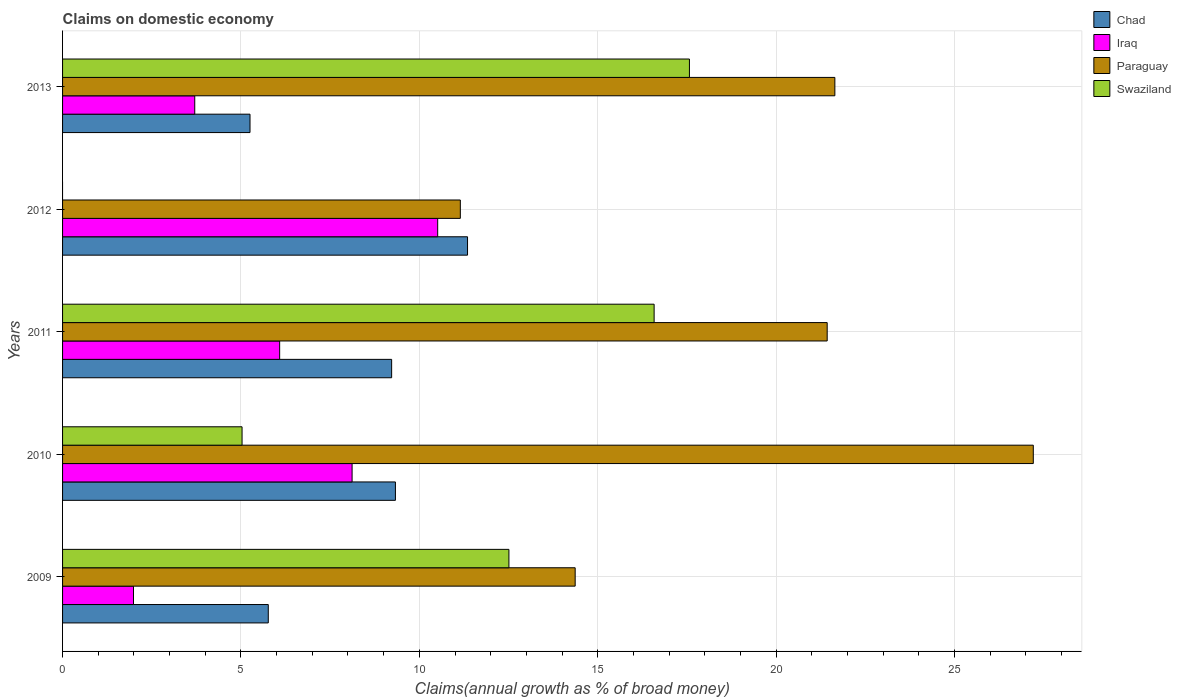How many groups of bars are there?
Your answer should be compact. 5. How many bars are there on the 3rd tick from the top?
Your response must be concise. 4. How many bars are there on the 2nd tick from the bottom?
Keep it short and to the point. 4. What is the label of the 5th group of bars from the top?
Your answer should be compact. 2009. What is the percentage of broad money claimed on domestic economy in Iraq in 2010?
Keep it short and to the point. 8.12. Across all years, what is the maximum percentage of broad money claimed on domestic economy in Chad?
Keep it short and to the point. 11.35. Across all years, what is the minimum percentage of broad money claimed on domestic economy in Paraguay?
Keep it short and to the point. 11.15. In which year was the percentage of broad money claimed on domestic economy in Chad maximum?
Keep it short and to the point. 2012. What is the total percentage of broad money claimed on domestic economy in Iraq in the graph?
Provide a succinct answer. 30.41. What is the difference between the percentage of broad money claimed on domestic economy in Swaziland in 2009 and that in 2010?
Make the answer very short. 7.48. What is the difference between the percentage of broad money claimed on domestic economy in Iraq in 2010 and the percentage of broad money claimed on domestic economy in Paraguay in 2013?
Ensure brevity in your answer.  -13.53. What is the average percentage of broad money claimed on domestic economy in Swaziland per year?
Make the answer very short. 10.34. In the year 2009, what is the difference between the percentage of broad money claimed on domestic economy in Iraq and percentage of broad money claimed on domestic economy in Chad?
Keep it short and to the point. -3.78. In how many years, is the percentage of broad money claimed on domestic economy in Chad greater than 7 %?
Provide a succinct answer. 3. What is the ratio of the percentage of broad money claimed on domestic economy in Chad in 2011 to that in 2013?
Give a very brief answer. 1.76. Is the percentage of broad money claimed on domestic economy in Paraguay in 2009 less than that in 2011?
Offer a very short reply. Yes. What is the difference between the highest and the second highest percentage of broad money claimed on domestic economy in Swaziland?
Make the answer very short. 0.99. What is the difference between the highest and the lowest percentage of broad money claimed on domestic economy in Chad?
Your response must be concise. 6.1. Is it the case that in every year, the sum of the percentage of broad money claimed on domestic economy in Paraguay and percentage of broad money claimed on domestic economy in Iraq is greater than the sum of percentage of broad money claimed on domestic economy in Swaziland and percentage of broad money claimed on domestic economy in Chad?
Your response must be concise. Yes. How many bars are there?
Give a very brief answer. 19. How many years are there in the graph?
Provide a short and direct response. 5. What is the difference between two consecutive major ticks on the X-axis?
Keep it short and to the point. 5. Where does the legend appear in the graph?
Ensure brevity in your answer.  Top right. How many legend labels are there?
Provide a short and direct response. 4. How are the legend labels stacked?
Provide a short and direct response. Vertical. What is the title of the graph?
Provide a succinct answer. Claims on domestic economy. What is the label or title of the X-axis?
Your response must be concise. Claims(annual growth as % of broad money). What is the Claims(annual growth as % of broad money) in Chad in 2009?
Provide a short and direct response. 5.77. What is the Claims(annual growth as % of broad money) of Iraq in 2009?
Your answer should be compact. 1.99. What is the Claims(annual growth as % of broad money) of Paraguay in 2009?
Ensure brevity in your answer.  14.37. What is the Claims(annual growth as % of broad money) of Swaziland in 2009?
Ensure brevity in your answer.  12.51. What is the Claims(annual growth as % of broad money) in Chad in 2010?
Your answer should be compact. 9.33. What is the Claims(annual growth as % of broad money) in Iraq in 2010?
Make the answer very short. 8.12. What is the Claims(annual growth as % of broad money) of Paraguay in 2010?
Your answer should be compact. 27.21. What is the Claims(annual growth as % of broad money) of Swaziland in 2010?
Your response must be concise. 5.03. What is the Claims(annual growth as % of broad money) in Chad in 2011?
Keep it short and to the point. 9.22. What is the Claims(annual growth as % of broad money) of Iraq in 2011?
Your answer should be very brief. 6.09. What is the Claims(annual growth as % of broad money) of Paraguay in 2011?
Give a very brief answer. 21.43. What is the Claims(annual growth as % of broad money) of Swaziland in 2011?
Offer a very short reply. 16.58. What is the Claims(annual growth as % of broad money) of Chad in 2012?
Offer a very short reply. 11.35. What is the Claims(annual growth as % of broad money) in Iraq in 2012?
Your response must be concise. 10.51. What is the Claims(annual growth as % of broad money) of Paraguay in 2012?
Make the answer very short. 11.15. What is the Claims(annual growth as % of broad money) of Chad in 2013?
Ensure brevity in your answer.  5.25. What is the Claims(annual growth as % of broad money) in Iraq in 2013?
Your answer should be very brief. 3.71. What is the Claims(annual growth as % of broad money) in Paraguay in 2013?
Your answer should be compact. 21.65. What is the Claims(annual growth as % of broad money) of Swaziland in 2013?
Keep it short and to the point. 17.57. Across all years, what is the maximum Claims(annual growth as % of broad money) of Chad?
Ensure brevity in your answer.  11.35. Across all years, what is the maximum Claims(annual growth as % of broad money) of Iraq?
Your answer should be compact. 10.51. Across all years, what is the maximum Claims(annual growth as % of broad money) of Paraguay?
Offer a very short reply. 27.21. Across all years, what is the maximum Claims(annual growth as % of broad money) in Swaziland?
Your answer should be compact. 17.57. Across all years, what is the minimum Claims(annual growth as % of broad money) of Chad?
Your answer should be compact. 5.25. Across all years, what is the minimum Claims(annual growth as % of broad money) of Iraq?
Provide a short and direct response. 1.99. Across all years, what is the minimum Claims(annual growth as % of broad money) of Paraguay?
Your response must be concise. 11.15. Across all years, what is the minimum Claims(annual growth as % of broad money) in Swaziland?
Offer a very short reply. 0. What is the total Claims(annual growth as % of broad money) in Chad in the graph?
Offer a very short reply. 40.93. What is the total Claims(annual growth as % of broad money) of Iraq in the graph?
Provide a short and direct response. 30.41. What is the total Claims(annual growth as % of broad money) in Paraguay in the graph?
Make the answer very short. 95.81. What is the total Claims(annual growth as % of broad money) of Swaziland in the graph?
Your answer should be compact. 51.7. What is the difference between the Claims(annual growth as % of broad money) of Chad in 2009 and that in 2010?
Keep it short and to the point. -3.56. What is the difference between the Claims(annual growth as % of broad money) of Iraq in 2009 and that in 2010?
Your answer should be compact. -6.13. What is the difference between the Claims(annual growth as % of broad money) of Paraguay in 2009 and that in 2010?
Provide a short and direct response. -12.84. What is the difference between the Claims(annual growth as % of broad money) of Swaziland in 2009 and that in 2010?
Offer a terse response. 7.48. What is the difference between the Claims(annual growth as % of broad money) of Chad in 2009 and that in 2011?
Provide a succinct answer. -3.46. What is the difference between the Claims(annual growth as % of broad money) in Iraq in 2009 and that in 2011?
Give a very brief answer. -4.1. What is the difference between the Claims(annual growth as % of broad money) in Paraguay in 2009 and that in 2011?
Keep it short and to the point. -7.06. What is the difference between the Claims(annual growth as % of broad money) of Swaziland in 2009 and that in 2011?
Ensure brevity in your answer.  -4.07. What is the difference between the Claims(annual growth as % of broad money) of Chad in 2009 and that in 2012?
Give a very brief answer. -5.59. What is the difference between the Claims(annual growth as % of broad money) of Iraq in 2009 and that in 2012?
Offer a terse response. -8.53. What is the difference between the Claims(annual growth as % of broad money) of Paraguay in 2009 and that in 2012?
Offer a very short reply. 3.22. What is the difference between the Claims(annual growth as % of broad money) of Chad in 2009 and that in 2013?
Provide a succinct answer. 0.51. What is the difference between the Claims(annual growth as % of broad money) in Iraq in 2009 and that in 2013?
Your answer should be compact. -1.72. What is the difference between the Claims(annual growth as % of broad money) of Paraguay in 2009 and that in 2013?
Provide a short and direct response. -7.28. What is the difference between the Claims(annual growth as % of broad money) in Swaziland in 2009 and that in 2013?
Ensure brevity in your answer.  -5.06. What is the difference between the Claims(annual growth as % of broad money) of Chad in 2010 and that in 2011?
Your answer should be compact. 0.11. What is the difference between the Claims(annual growth as % of broad money) of Iraq in 2010 and that in 2011?
Provide a succinct answer. 2.03. What is the difference between the Claims(annual growth as % of broad money) of Paraguay in 2010 and that in 2011?
Give a very brief answer. 5.78. What is the difference between the Claims(annual growth as % of broad money) of Swaziland in 2010 and that in 2011?
Offer a very short reply. -11.55. What is the difference between the Claims(annual growth as % of broad money) in Chad in 2010 and that in 2012?
Your answer should be very brief. -2.02. What is the difference between the Claims(annual growth as % of broad money) of Iraq in 2010 and that in 2012?
Give a very brief answer. -2.4. What is the difference between the Claims(annual growth as % of broad money) in Paraguay in 2010 and that in 2012?
Your response must be concise. 16.06. What is the difference between the Claims(annual growth as % of broad money) in Chad in 2010 and that in 2013?
Give a very brief answer. 4.08. What is the difference between the Claims(annual growth as % of broad money) in Iraq in 2010 and that in 2013?
Ensure brevity in your answer.  4.41. What is the difference between the Claims(annual growth as % of broad money) of Paraguay in 2010 and that in 2013?
Provide a succinct answer. 5.56. What is the difference between the Claims(annual growth as % of broad money) of Swaziland in 2010 and that in 2013?
Give a very brief answer. -12.54. What is the difference between the Claims(annual growth as % of broad money) of Chad in 2011 and that in 2012?
Give a very brief answer. -2.13. What is the difference between the Claims(annual growth as % of broad money) of Iraq in 2011 and that in 2012?
Your response must be concise. -4.43. What is the difference between the Claims(annual growth as % of broad money) in Paraguay in 2011 and that in 2012?
Provide a succinct answer. 10.28. What is the difference between the Claims(annual growth as % of broad money) in Chad in 2011 and that in 2013?
Give a very brief answer. 3.97. What is the difference between the Claims(annual growth as % of broad money) of Iraq in 2011 and that in 2013?
Ensure brevity in your answer.  2.38. What is the difference between the Claims(annual growth as % of broad money) of Paraguay in 2011 and that in 2013?
Offer a terse response. -0.22. What is the difference between the Claims(annual growth as % of broad money) of Swaziland in 2011 and that in 2013?
Give a very brief answer. -0.99. What is the difference between the Claims(annual growth as % of broad money) in Chad in 2012 and that in 2013?
Provide a succinct answer. 6.1. What is the difference between the Claims(annual growth as % of broad money) in Iraq in 2012 and that in 2013?
Offer a terse response. 6.81. What is the difference between the Claims(annual growth as % of broad money) in Paraguay in 2012 and that in 2013?
Provide a succinct answer. -10.5. What is the difference between the Claims(annual growth as % of broad money) of Chad in 2009 and the Claims(annual growth as % of broad money) of Iraq in 2010?
Offer a very short reply. -2.35. What is the difference between the Claims(annual growth as % of broad money) of Chad in 2009 and the Claims(annual growth as % of broad money) of Paraguay in 2010?
Your answer should be very brief. -21.44. What is the difference between the Claims(annual growth as % of broad money) of Chad in 2009 and the Claims(annual growth as % of broad money) of Swaziland in 2010?
Keep it short and to the point. 0.73. What is the difference between the Claims(annual growth as % of broad money) in Iraq in 2009 and the Claims(annual growth as % of broad money) in Paraguay in 2010?
Your response must be concise. -25.22. What is the difference between the Claims(annual growth as % of broad money) in Iraq in 2009 and the Claims(annual growth as % of broad money) in Swaziland in 2010?
Give a very brief answer. -3.04. What is the difference between the Claims(annual growth as % of broad money) in Paraguay in 2009 and the Claims(annual growth as % of broad money) in Swaziland in 2010?
Ensure brevity in your answer.  9.34. What is the difference between the Claims(annual growth as % of broad money) of Chad in 2009 and the Claims(annual growth as % of broad money) of Iraq in 2011?
Provide a succinct answer. -0.32. What is the difference between the Claims(annual growth as % of broad money) in Chad in 2009 and the Claims(annual growth as % of broad money) in Paraguay in 2011?
Ensure brevity in your answer.  -15.67. What is the difference between the Claims(annual growth as % of broad money) in Chad in 2009 and the Claims(annual growth as % of broad money) in Swaziland in 2011?
Your answer should be compact. -10.82. What is the difference between the Claims(annual growth as % of broad money) in Iraq in 2009 and the Claims(annual growth as % of broad money) in Paraguay in 2011?
Make the answer very short. -19.44. What is the difference between the Claims(annual growth as % of broad money) of Iraq in 2009 and the Claims(annual growth as % of broad money) of Swaziland in 2011?
Provide a succinct answer. -14.59. What is the difference between the Claims(annual growth as % of broad money) of Paraguay in 2009 and the Claims(annual growth as % of broad money) of Swaziland in 2011?
Make the answer very short. -2.21. What is the difference between the Claims(annual growth as % of broad money) in Chad in 2009 and the Claims(annual growth as % of broad money) in Iraq in 2012?
Provide a succinct answer. -4.75. What is the difference between the Claims(annual growth as % of broad money) in Chad in 2009 and the Claims(annual growth as % of broad money) in Paraguay in 2012?
Ensure brevity in your answer.  -5.38. What is the difference between the Claims(annual growth as % of broad money) of Iraq in 2009 and the Claims(annual growth as % of broad money) of Paraguay in 2012?
Your answer should be very brief. -9.16. What is the difference between the Claims(annual growth as % of broad money) of Chad in 2009 and the Claims(annual growth as % of broad money) of Iraq in 2013?
Ensure brevity in your answer.  2.06. What is the difference between the Claims(annual growth as % of broad money) of Chad in 2009 and the Claims(annual growth as % of broad money) of Paraguay in 2013?
Offer a very short reply. -15.88. What is the difference between the Claims(annual growth as % of broad money) in Chad in 2009 and the Claims(annual growth as % of broad money) in Swaziland in 2013?
Your response must be concise. -11.81. What is the difference between the Claims(annual growth as % of broad money) in Iraq in 2009 and the Claims(annual growth as % of broad money) in Paraguay in 2013?
Your answer should be very brief. -19.66. What is the difference between the Claims(annual growth as % of broad money) of Iraq in 2009 and the Claims(annual growth as % of broad money) of Swaziland in 2013?
Provide a short and direct response. -15.58. What is the difference between the Claims(annual growth as % of broad money) of Paraguay in 2009 and the Claims(annual growth as % of broad money) of Swaziland in 2013?
Provide a short and direct response. -3.2. What is the difference between the Claims(annual growth as % of broad money) of Chad in 2010 and the Claims(annual growth as % of broad money) of Iraq in 2011?
Give a very brief answer. 3.24. What is the difference between the Claims(annual growth as % of broad money) of Chad in 2010 and the Claims(annual growth as % of broad money) of Paraguay in 2011?
Offer a very short reply. -12.1. What is the difference between the Claims(annual growth as % of broad money) of Chad in 2010 and the Claims(annual growth as % of broad money) of Swaziland in 2011?
Your answer should be very brief. -7.25. What is the difference between the Claims(annual growth as % of broad money) of Iraq in 2010 and the Claims(annual growth as % of broad money) of Paraguay in 2011?
Provide a succinct answer. -13.32. What is the difference between the Claims(annual growth as % of broad money) in Iraq in 2010 and the Claims(annual growth as % of broad money) in Swaziland in 2011?
Provide a succinct answer. -8.47. What is the difference between the Claims(annual growth as % of broad money) in Paraguay in 2010 and the Claims(annual growth as % of broad money) in Swaziland in 2011?
Your answer should be very brief. 10.63. What is the difference between the Claims(annual growth as % of broad money) in Chad in 2010 and the Claims(annual growth as % of broad money) in Iraq in 2012?
Ensure brevity in your answer.  -1.18. What is the difference between the Claims(annual growth as % of broad money) of Chad in 2010 and the Claims(annual growth as % of broad money) of Paraguay in 2012?
Your answer should be very brief. -1.82. What is the difference between the Claims(annual growth as % of broad money) of Iraq in 2010 and the Claims(annual growth as % of broad money) of Paraguay in 2012?
Offer a terse response. -3.03. What is the difference between the Claims(annual growth as % of broad money) in Chad in 2010 and the Claims(annual growth as % of broad money) in Iraq in 2013?
Offer a terse response. 5.62. What is the difference between the Claims(annual growth as % of broad money) in Chad in 2010 and the Claims(annual growth as % of broad money) in Paraguay in 2013?
Keep it short and to the point. -12.32. What is the difference between the Claims(annual growth as % of broad money) in Chad in 2010 and the Claims(annual growth as % of broad money) in Swaziland in 2013?
Keep it short and to the point. -8.24. What is the difference between the Claims(annual growth as % of broad money) in Iraq in 2010 and the Claims(annual growth as % of broad money) in Paraguay in 2013?
Provide a short and direct response. -13.53. What is the difference between the Claims(annual growth as % of broad money) of Iraq in 2010 and the Claims(annual growth as % of broad money) of Swaziland in 2013?
Ensure brevity in your answer.  -9.46. What is the difference between the Claims(annual growth as % of broad money) of Paraguay in 2010 and the Claims(annual growth as % of broad money) of Swaziland in 2013?
Offer a terse response. 9.64. What is the difference between the Claims(annual growth as % of broad money) of Chad in 2011 and the Claims(annual growth as % of broad money) of Iraq in 2012?
Provide a short and direct response. -1.29. What is the difference between the Claims(annual growth as % of broad money) in Chad in 2011 and the Claims(annual growth as % of broad money) in Paraguay in 2012?
Your response must be concise. -1.93. What is the difference between the Claims(annual growth as % of broad money) in Iraq in 2011 and the Claims(annual growth as % of broad money) in Paraguay in 2012?
Provide a succinct answer. -5.06. What is the difference between the Claims(annual growth as % of broad money) of Chad in 2011 and the Claims(annual growth as % of broad money) of Iraq in 2013?
Your answer should be compact. 5.52. What is the difference between the Claims(annual growth as % of broad money) in Chad in 2011 and the Claims(annual growth as % of broad money) in Paraguay in 2013?
Offer a very short reply. -12.42. What is the difference between the Claims(annual growth as % of broad money) of Chad in 2011 and the Claims(annual growth as % of broad money) of Swaziland in 2013?
Make the answer very short. -8.35. What is the difference between the Claims(annual growth as % of broad money) of Iraq in 2011 and the Claims(annual growth as % of broad money) of Paraguay in 2013?
Offer a very short reply. -15.56. What is the difference between the Claims(annual growth as % of broad money) of Iraq in 2011 and the Claims(annual growth as % of broad money) of Swaziland in 2013?
Give a very brief answer. -11.49. What is the difference between the Claims(annual growth as % of broad money) in Paraguay in 2011 and the Claims(annual growth as % of broad money) in Swaziland in 2013?
Offer a terse response. 3.86. What is the difference between the Claims(annual growth as % of broad money) of Chad in 2012 and the Claims(annual growth as % of broad money) of Iraq in 2013?
Make the answer very short. 7.65. What is the difference between the Claims(annual growth as % of broad money) of Chad in 2012 and the Claims(annual growth as % of broad money) of Paraguay in 2013?
Give a very brief answer. -10.3. What is the difference between the Claims(annual growth as % of broad money) in Chad in 2012 and the Claims(annual growth as % of broad money) in Swaziland in 2013?
Your answer should be very brief. -6.22. What is the difference between the Claims(annual growth as % of broad money) in Iraq in 2012 and the Claims(annual growth as % of broad money) in Paraguay in 2013?
Provide a short and direct response. -11.13. What is the difference between the Claims(annual growth as % of broad money) of Iraq in 2012 and the Claims(annual growth as % of broad money) of Swaziland in 2013?
Give a very brief answer. -7.06. What is the difference between the Claims(annual growth as % of broad money) of Paraguay in 2012 and the Claims(annual growth as % of broad money) of Swaziland in 2013?
Give a very brief answer. -6.42. What is the average Claims(annual growth as % of broad money) in Chad per year?
Offer a terse response. 8.19. What is the average Claims(annual growth as % of broad money) of Iraq per year?
Your response must be concise. 6.08. What is the average Claims(annual growth as % of broad money) of Paraguay per year?
Make the answer very short. 19.16. What is the average Claims(annual growth as % of broad money) of Swaziland per year?
Make the answer very short. 10.34. In the year 2009, what is the difference between the Claims(annual growth as % of broad money) in Chad and Claims(annual growth as % of broad money) in Iraq?
Offer a terse response. 3.78. In the year 2009, what is the difference between the Claims(annual growth as % of broad money) in Chad and Claims(annual growth as % of broad money) in Paraguay?
Your response must be concise. -8.6. In the year 2009, what is the difference between the Claims(annual growth as % of broad money) of Chad and Claims(annual growth as % of broad money) of Swaziland?
Keep it short and to the point. -6.75. In the year 2009, what is the difference between the Claims(annual growth as % of broad money) in Iraq and Claims(annual growth as % of broad money) in Paraguay?
Your answer should be very brief. -12.38. In the year 2009, what is the difference between the Claims(annual growth as % of broad money) in Iraq and Claims(annual growth as % of broad money) in Swaziland?
Your answer should be compact. -10.52. In the year 2009, what is the difference between the Claims(annual growth as % of broad money) of Paraguay and Claims(annual growth as % of broad money) of Swaziland?
Your answer should be very brief. 1.86. In the year 2010, what is the difference between the Claims(annual growth as % of broad money) of Chad and Claims(annual growth as % of broad money) of Iraq?
Keep it short and to the point. 1.21. In the year 2010, what is the difference between the Claims(annual growth as % of broad money) in Chad and Claims(annual growth as % of broad money) in Paraguay?
Offer a terse response. -17.88. In the year 2010, what is the difference between the Claims(annual growth as % of broad money) in Chad and Claims(annual growth as % of broad money) in Swaziland?
Your response must be concise. 4.3. In the year 2010, what is the difference between the Claims(annual growth as % of broad money) of Iraq and Claims(annual growth as % of broad money) of Paraguay?
Provide a short and direct response. -19.09. In the year 2010, what is the difference between the Claims(annual growth as % of broad money) in Iraq and Claims(annual growth as % of broad money) in Swaziland?
Make the answer very short. 3.08. In the year 2010, what is the difference between the Claims(annual growth as % of broad money) of Paraguay and Claims(annual growth as % of broad money) of Swaziland?
Make the answer very short. 22.18. In the year 2011, what is the difference between the Claims(annual growth as % of broad money) in Chad and Claims(annual growth as % of broad money) in Iraq?
Ensure brevity in your answer.  3.14. In the year 2011, what is the difference between the Claims(annual growth as % of broad money) of Chad and Claims(annual growth as % of broad money) of Paraguay?
Provide a succinct answer. -12.21. In the year 2011, what is the difference between the Claims(annual growth as % of broad money) of Chad and Claims(annual growth as % of broad money) of Swaziland?
Provide a succinct answer. -7.36. In the year 2011, what is the difference between the Claims(annual growth as % of broad money) of Iraq and Claims(annual growth as % of broad money) of Paraguay?
Your answer should be very brief. -15.35. In the year 2011, what is the difference between the Claims(annual growth as % of broad money) in Iraq and Claims(annual growth as % of broad money) in Swaziland?
Offer a terse response. -10.5. In the year 2011, what is the difference between the Claims(annual growth as % of broad money) of Paraguay and Claims(annual growth as % of broad money) of Swaziland?
Give a very brief answer. 4.85. In the year 2012, what is the difference between the Claims(annual growth as % of broad money) in Chad and Claims(annual growth as % of broad money) in Iraq?
Offer a very short reply. 0.84. In the year 2012, what is the difference between the Claims(annual growth as % of broad money) of Chad and Claims(annual growth as % of broad money) of Paraguay?
Keep it short and to the point. 0.2. In the year 2012, what is the difference between the Claims(annual growth as % of broad money) of Iraq and Claims(annual growth as % of broad money) of Paraguay?
Your response must be concise. -0.63. In the year 2013, what is the difference between the Claims(annual growth as % of broad money) of Chad and Claims(annual growth as % of broad money) of Iraq?
Provide a succinct answer. 1.55. In the year 2013, what is the difference between the Claims(annual growth as % of broad money) of Chad and Claims(annual growth as % of broad money) of Paraguay?
Keep it short and to the point. -16.39. In the year 2013, what is the difference between the Claims(annual growth as % of broad money) of Chad and Claims(annual growth as % of broad money) of Swaziland?
Provide a short and direct response. -12.32. In the year 2013, what is the difference between the Claims(annual growth as % of broad money) in Iraq and Claims(annual growth as % of broad money) in Paraguay?
Provide a short and direct response. -17.94. In the year 2013, what is the difference between the Claims(annual growth as % of broad money) of Iraq and Claims(annual growth as % of broad money) of Swaziland?
Offer a terse response. -13.87. In the year 2013, what is the difference between the Claims(annual growth as % of broad money) in Paraguay and Claims(annual growth as % of broad money) in Swaziland?
Give a very brief answer. 4.08. What is the ratio of the Claims(annual growth as % of broad money) in Chad in 2009 to that in 2010?
Ensure brevity in your answer.  0.62. What is the ratio of the Claims(annual growth as % of broad money) of Iraq in 2009 to that in 2010?
Ensure brevity in your answer.  0.24. What is the ratio of the Claims(annual growth as % of broad money) of Paraguay in 2009 to that in 2010?
Make the answer very short. 0.53. What is the ratio of the Claims(annual growth as % of broad money) in Swaziland in 2009 to that in 2010?
Ensure brevity in your answer.  2.49. What is the ratio of the Claims(annual growth as % of broad money) in Chad in 2009 to that in 2011?
Keep it short and to the point. 0.63. What is the ratio of the Claims(annual growth as % of broad money) in Iraq in 2009 to that in 2011?
Provide a short and direct response. 0.33. What is the ratio of the Claims(annual growth as % of broad money) in Paraguay in 2009 to that in 2011?
Make the answer very short. 0.67. What is the ratio of the Claims(annual growth as % of broad money) of Swaziland in 2009 to that in 2011?
Keep it short and to the point. 0.75. What is the ratio of the Claims(annual growth as % of broad money) in Chad in 2009 to that in 2012?
Provide a short and direct response. 0.51. What is the ratio of the Claims(annual growth as % of broad money) of Iraq in 2009 to that in 2012?
Keep it short and to the point. 0.19. What is the ratio of the Claims(annual growth as % of broad money) of Paraguay in 2009 to that in 2012?
Offer a very short reply. 1.29. What is the ratio of the Claims(annual growth as % of broad money) of Chad in 2009 to that in 2013?
Offer a very short reply. 1.1. What is the ratio of the Claims(annual growth as % of broad money) in Iraq in 2009 to that in 2013?
Provide a short and direct response. 0.54. What is the ratio of the Claims(annual growth as % of broad money) in Paraguay in 2009 to that in 2013?
Provide a succinct answer. 0.66. What is the ratio of the Claims(annual growth as % of broad money) of Swaziland in 2009 to that in 2013?
Give a very brief answer. 0.71. What is the ratio of the Claims(annual growth as % of broad money) of Chad in 2010 to that in 2011?
Offer a terse response. 1.01. What is the ratio of the Claims(annual growth as % of broad money) in Iraq in 2010 to that in 2011?
Your answer should be compact. 1.33. What is the ratio of the Claims(annual growth as % of broad money) of Paraguay in 2010 to that in 2011?
Give a very brief answer. 1.27. What is the ratio of the Claims(annual growth as % of broad money) in Swaziland in 2010 to that in 2011?
Give a very brief answer. 0.3. What is the ratio of the Claims(annual growth as % of broad money) of Chad in 2010 to that in 2012?
Your answer should be very brief. 0.82. What is the ratio of the Claims(annual growth as % of broad money) of Iraq in 2010 to that in 2012?
Offer a very short reply. 0.77. What is the ratio of the Claims(annual growth as % of broad money) of Paraguay in 2010 to that in 2012?
Offer a terse response. 2.44. What is the ratio of the Claims(annual growth as % of broad money) in Chad in 2010 to that in 2013?
Make the answer very short. 1.78. What is the ratio of the Claims(annual growth as % of broad money) of Iraq in 2010 to that in 2013?
Give a very brief answer. 2.19. What is the ratio of the Claims(annual growth as % of broad money) in Paraguay in 2010 to that in 2013?
Your answer should be compact. 1.26. What is the ratio of the Claims(annual growth as % of broad money) in Swaziland in 2010 to that in 2013?
Your answer should be very brief. 0.29. What is the ratio of the Claims(annual growth as % of broad money) of Chad in 2011 to that in 2012?
Your response must be concise. 0.81. What is the ratio of the Claims(annual growth as % of broad money) of Iraq in 2011 to that in 2012?
Ensure brevity in your answer.  0.58. What is the ratio of the Claims(annual growth as % of broad money) of Paraguay in 2011 to that in 2012?
Your answer should be compact. 1.92. What is the ratio of the Claims(annual growth as % of broad money) in Chad in 2011 to that in 2013?
Offer a terse response. 1.76. What is the ratio of the Claims(annual growth as % of broad money) of Iraq in 2011 to that in 2013?
Keep it short and to the point. 1.64. What is the ratio of the Claims(annual growth as % of broad money) in Swaziland in 2011 to that in 2013?
Ensure brevity in your answer.  0.94. What is the ratio of the Claims(annual growth as % of broad money) of Chad in 2012 to that in 2013?
Your answer should be very brief. 2.16. What is the ratio of the Claims(annual growth as % of broad money) in Iraq in 2012 to that in 2013?
Make the answer very short. 2.84. What is the ratio of the Claims(annual growth as % of broad money) of Paraguay in 2012 to that in 2013?
Offer a very short reply. 0.52. What is the difference between the highest and the second highest Claims(annual growth as % of broad money) of Chad?
Your answer should be compact. 2.02. What is the difference between the highest and the second highest Claims(annual growth as % of broad money) in Iraq?
Your response must be concise. 2.4. What is the difference between the highest and the second highest Claims(annual growth as % of broad money) in Paraguay?
Provide a short and direct response. 5.56. What is the difference between the highest and the second highest Claims(annual growth as % of broad money) in Swaziland?
Give a very brief answer. 0.99. What is the difference between the highest and the lowest Claims(annual growth as % of broad money) of Chad?
Ensure brevity in your answer.  6.1. What is the difference between the highest and the lowest Claims(annual growth as % of broad money) of Iraq?
Make the answer very short. 8.53. What is the difference between the highest and the lowest Claims(annual growth as % of broad money) of Paraguay?
Keep it short and to the point. 16.06. What is the difference between the highest and the lowest Claims(annual growth as % of broad money) in Swaziland?
Provide a short and direct response. 17.57. 